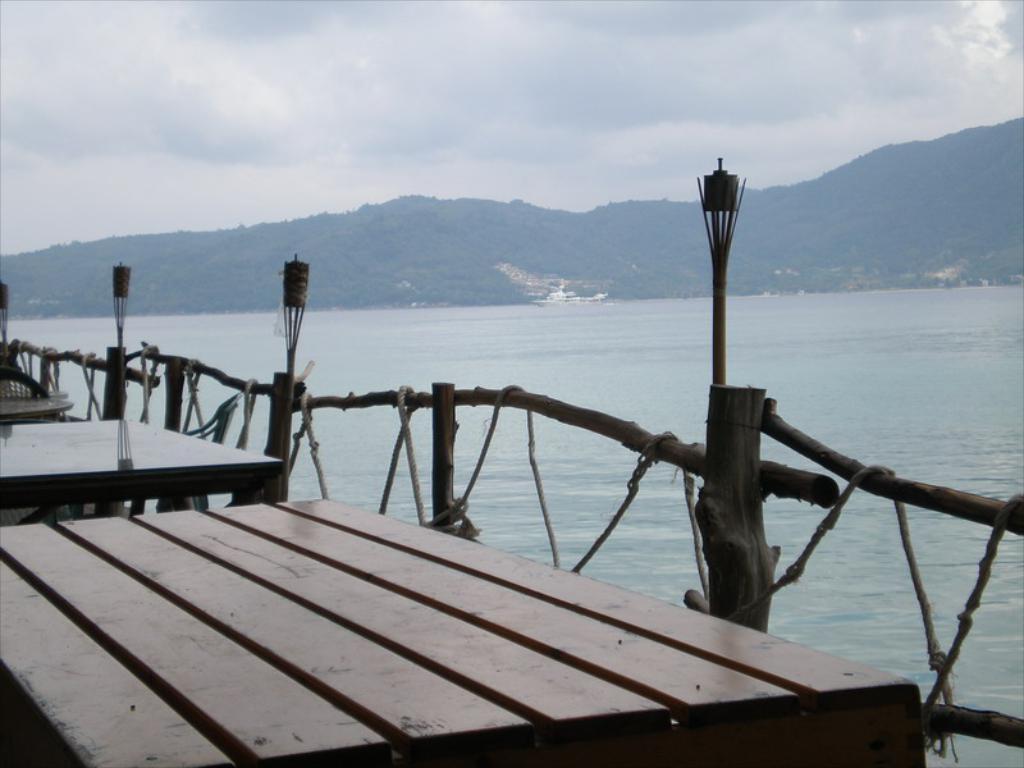What can be seen in the sky in the image? The sky with clouds is visible in the image. What type of natural feature is present in the image? There are hills in the image. What body of water is visible in the image? There is water visible in the image. What type of barrier is present in the image? A wooden fence is present in the image. What type of furniture is on the floor in the image? Tables are on the floor in the image. What type of baseball experience can be seen in the image? There is no baseball experience present in the image. What type of carpentry work is being done in the image? There is no carpentry work being done in the image. 